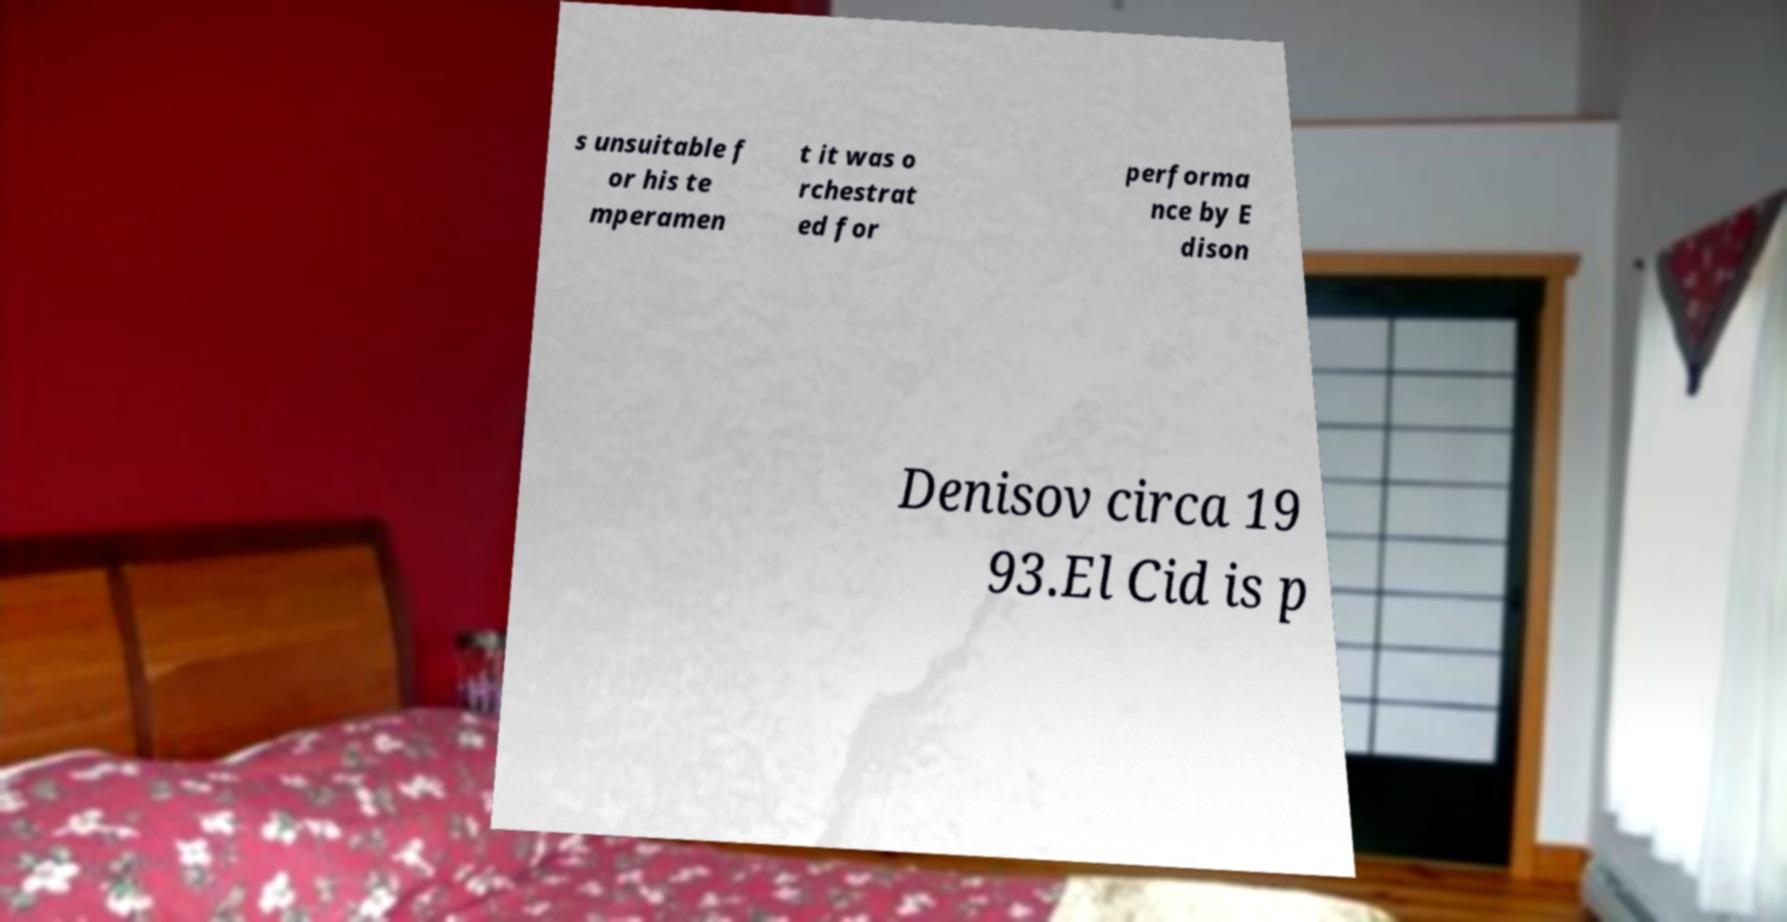Could you assist in decoding the text presented in this image and type it out clearly? s unsuitable f or his te mperamen t it was o rchestrat ed for performa nce by E dison Denisov circa 19 93.El Cid is p 